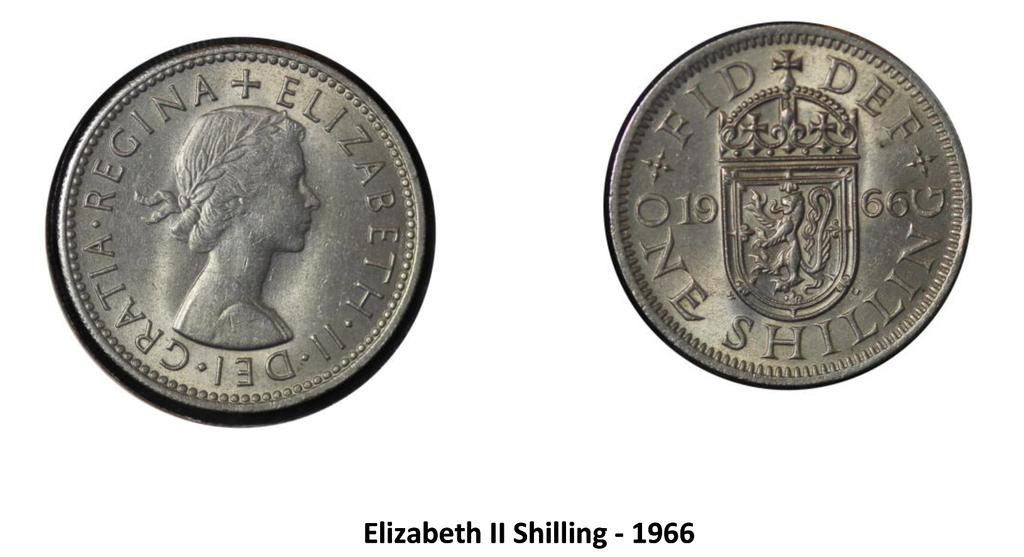What objects can be seen in the image? There are two coins in the image. What else is present in the image besides the coins? There is text in the image. What color is the background of the image? The background of the image is white. What type of disease is depicted in the image? There is no disease depicted in the image; it features two coins and text on a white background. How does the power of the coins compare to the power of a magnet in the image? There is no magnet present in the image, so it is not possible to make a comparison. 